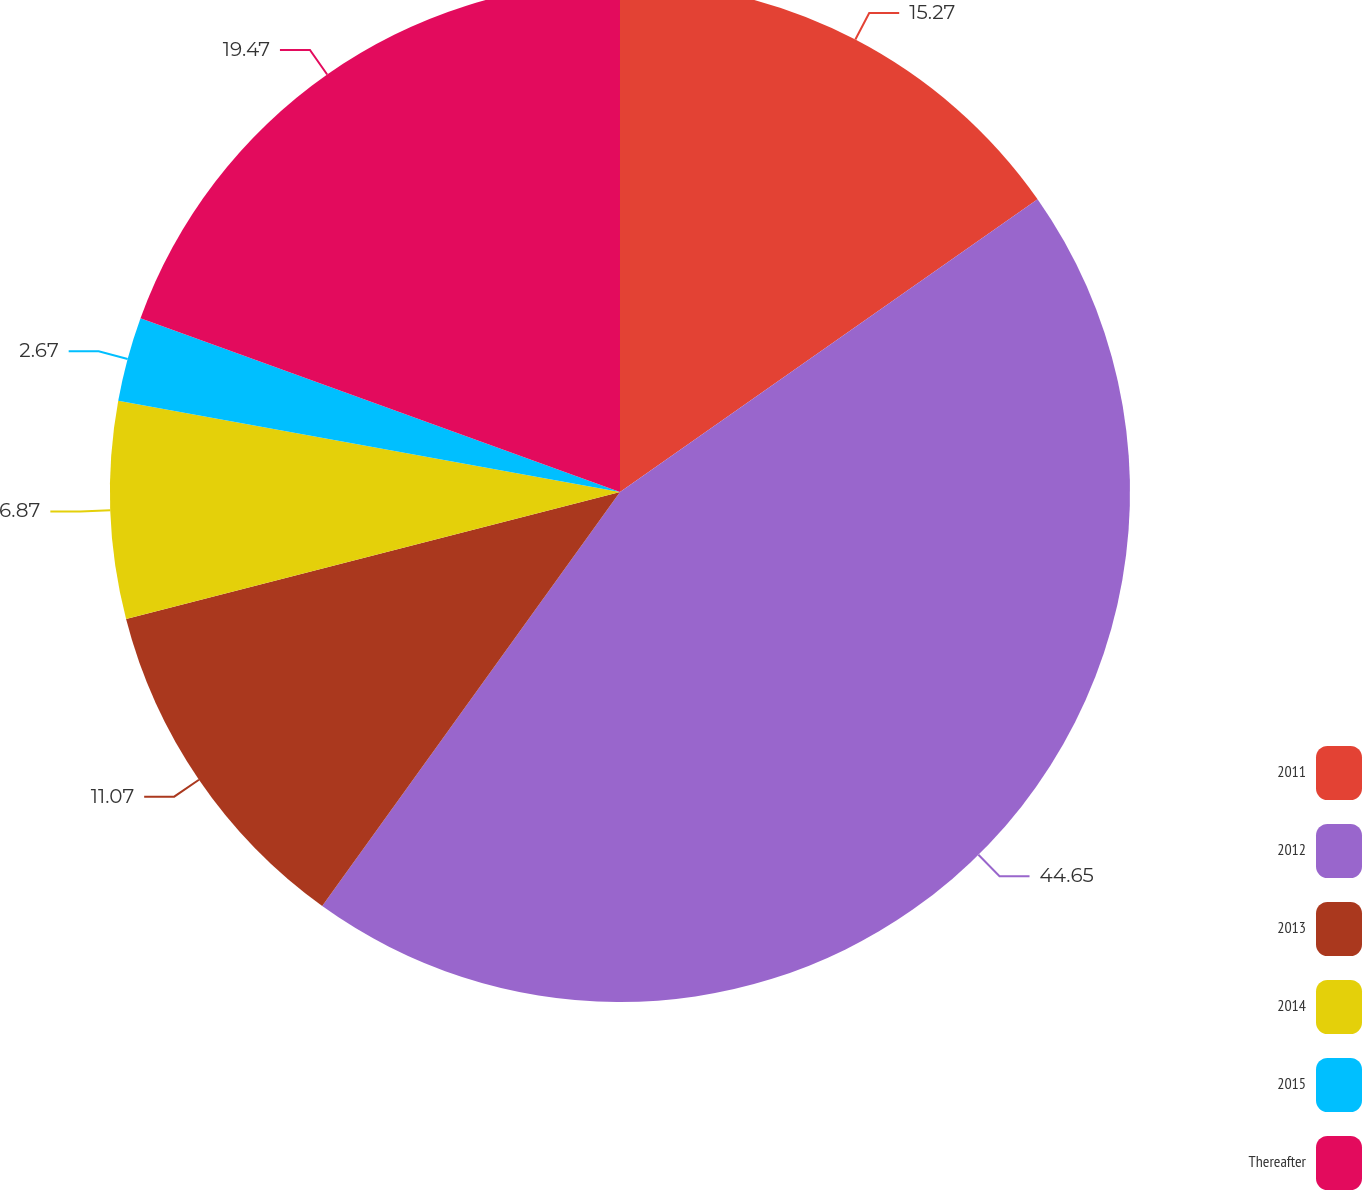Convert chart. <chart><loc_0><loc_0><loc_500><loc_500><pie_chart><fcel>2011<fcel>2012<fcel>2013<fcel>2014<fcel>2015<fcel>Thereafter<nl><fcel>15.27%<fcel>44.66%<fcel>11.07%<fcel>6.87%<fcel>2.67%<fcel>19.47%<nl></chart> 